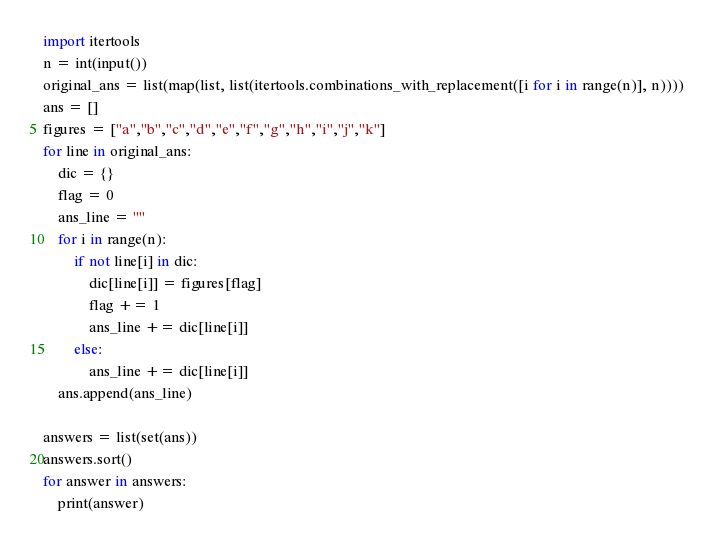Convert code to text. <code><loc_0><loc_0><loc_500><loc_500><_Python_>import itertools
n = int(input())
original_ans = list(map(list, list(itertools.combinations_with_replacement([i for i in range(n)], n))))
ans = []
figures = ["a","b","c","d","e","f","g","h","i","j","k"]
for line in original_ans:
    dic = {}
    flag = 0
    ans_line = ""
    for i in range(n):
        if not line[i] in dic:
            dic[line[i]] = figures[flag]
            flag += 1
            ans_line += dic[line[i]]
        else:
            ans_line += dic[line[i]]
    ans.append(ans_line)

answers = list(set(ans))
answers.sort()
for answer in answers:
    print(answer)
</code> 